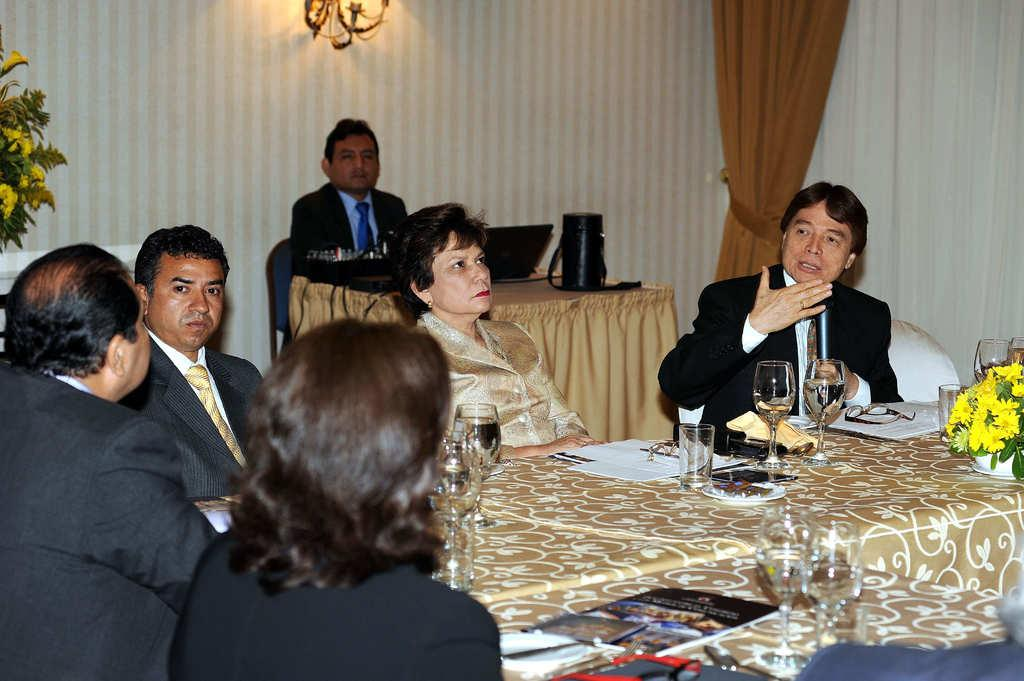What is hanging in the image? There is a curtain in the image. What is behind the curtain? There is a wall in the image. What are the people in the image doing? There are people sitting on chairs in the image. What is on the table in the image? There is a flower, glasses, and papers on the table. How many sisters are sitting on the chairs in the image? There is no mention of sisters in the image; only people are mentioned. What type of news can be seen on the papers in the image? There is no news present on the papers in the image; only papers are mentioned. 